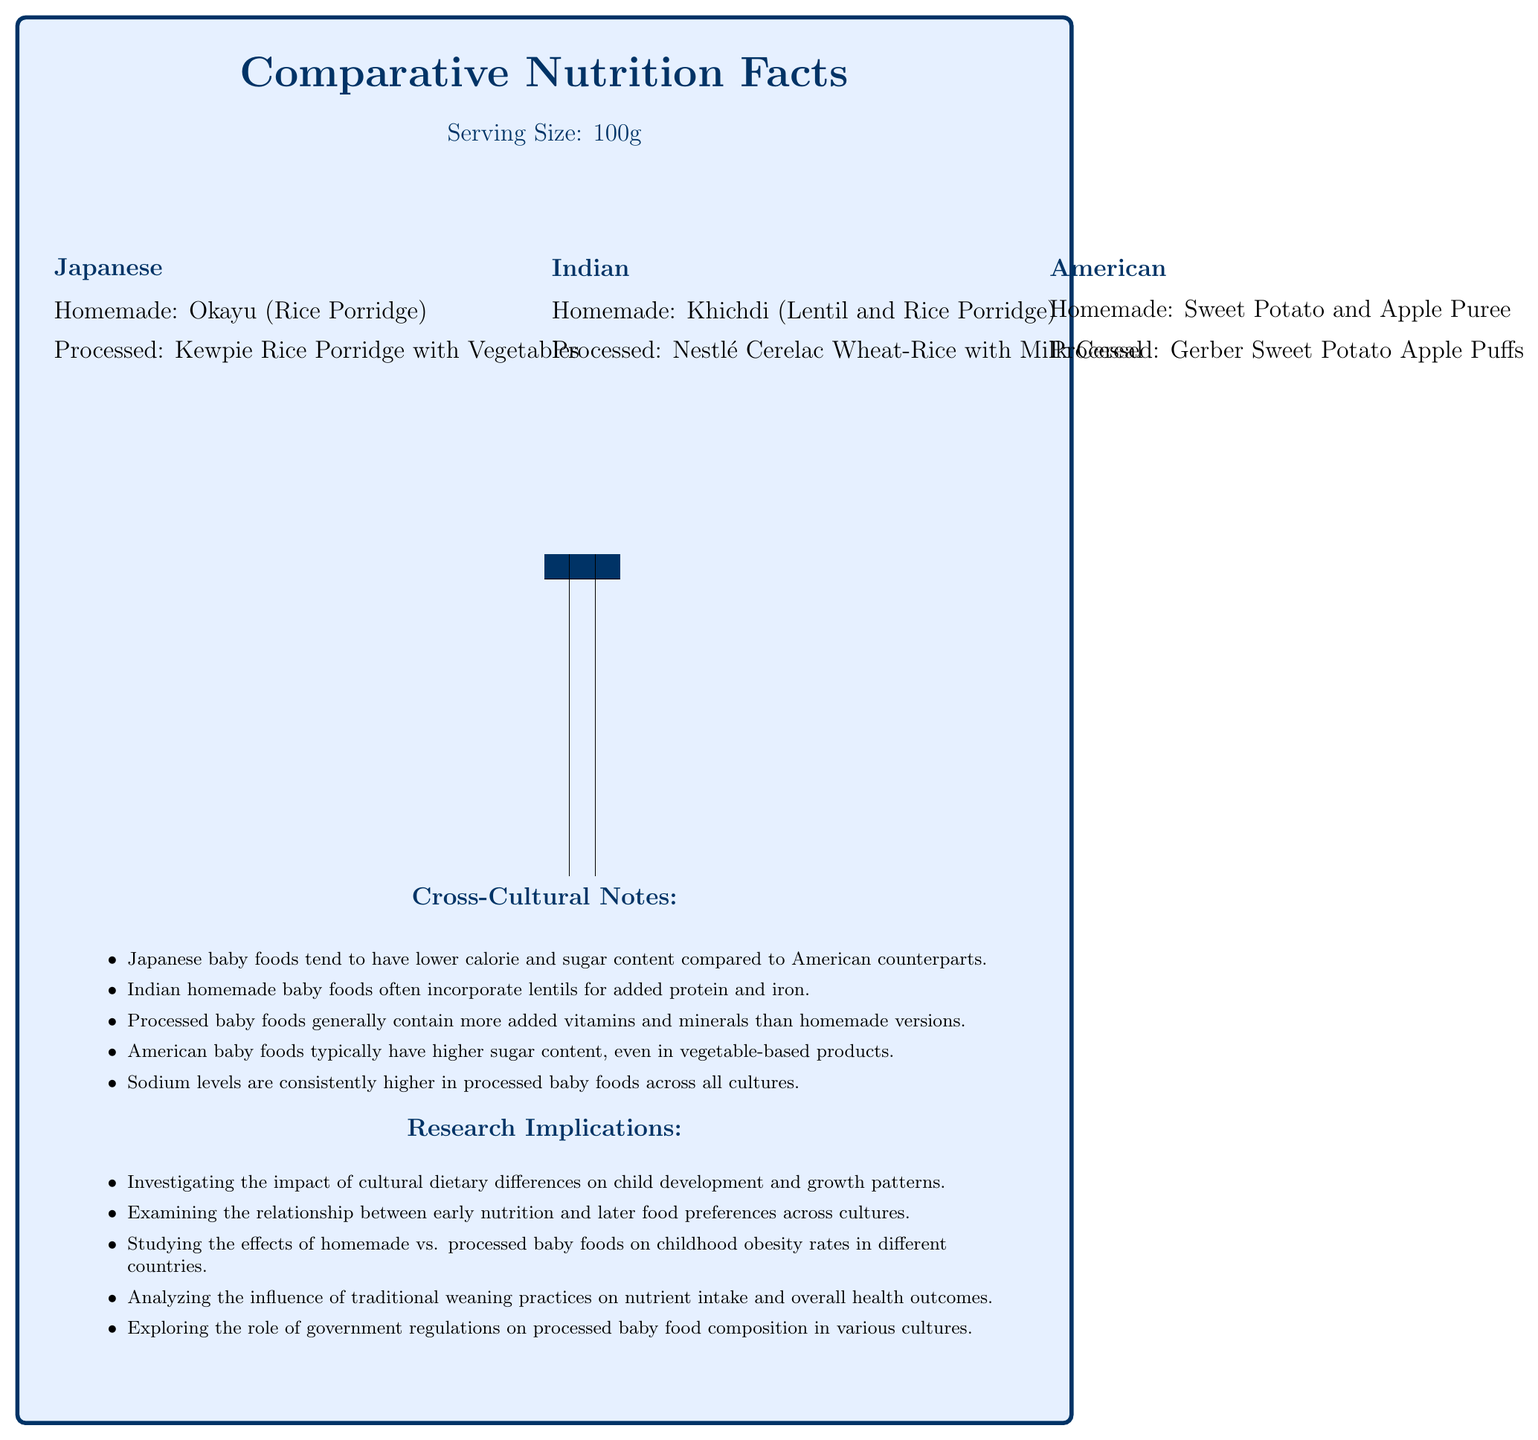What is the serving size for the baby foods compared in the document? The document states at the beginning that the serving size is 100g.
Answer: 100g Which processed baby food has the highest calorie content? A. Kewpie Rice Porridge with Vegetables B. Nestlé Cerelac Wheat-Rice with Milk Cereal C. Gerber Sweet Potato Apple Puffs D. Homemade Khichdi According to the comparative tables, the calorie content of "Kewpie Rice Porridge with Vegetables" is 52 kcal, "Nestlé Cerelac Wheat-Rice with Milk Cereal" is 101 kcal, and "Gerber Sweet Potato Apple Puffs" is 110 kcal. Therefore, Gerber Sweet Potato Apple Puffs has the highest calorie content among the processed foods.
Answer: C. Gerber Sweet Potato Apple Puffs Which culture's homemade baby food provides the most dietary fiber per serving? A. Japanese B. Indian C. American The document shows that the dietary fiber content in homemade baby foods is 0.3g (Japanese), 2.1g (Indian), and 2.3g (American). Therefore, the Indian homemade baby food (Khichdi) provides the most dietary fiber.
Answer: B. Indian Do American baby foods have higher sugar content compared to Japanese baby foods? The cross-cultural notes section of the document mentions that American baby foods have higher sugar content compared to Japanese counterparts.
Answer: Yes How much protein do the American homemade and processed baby foods have? The American section of the comparative tables shows that the protein content in homemade Sweet Potato and Apple Puree is 0.9g, and the protein content in processed Gerber Sweet Potato Apple Puffs is 1g.
Answer: Homemade: 0.9g, Processed: 1g Which homemade baby food contains the most calcium (%)? According to the comparative tables, the calcium content in homemade baby foods is 2% (Japanese), 15% (Indian), and 20% (American). Therefore, American Sweet Potato and Apple Puree contains the most calcium among homemade foods.
Answer: Khichdi (Indian) Which vitamin is consistently higher in processed baby foods than in homemade across all cultures? All processed baby foods listed in the document (Japanese, Indian, and American) have higher vitamin A content compared to their homemade counterparts.
Answer: Vitamin A Summarize the main insights provided by the document. The document provides detailed nutritional comparisons and discusses implications for child development and nutrition research across different cultures.
Answer: The document compares the nutritional content of homemade and processed baby foods from Japanese, Indian, and American cultures. It shows differences in calories, fats, sugars, vitamins, and minerals. Cross-cultural notes highlight tendencies such as lower sugar content in Japanese foods and higher protein in Indian foods. The research implications suggest studying the impact of these differences on child health and examining traditional versus processed food influences. What is the sodium content in Japanese processed baby food? The Japanese section of the comparative tables shows that the sodium content in the processed baby food (Kewpie Rice Porridge with Vegetables) is 20 mg.
Answer: 20 mg Are Indian homemade baby foods higher in total carbohydrate content compared to processed Indian baby foods? The comparative tables show that the total carbohydrate content in homemade Khichdi (Indian) is 15.6g, whereas in processed Nestlé Cerelac Wheat-Rice with Milk Cereal it's 16.8g. Thus, processed Indian baby foods have higher carbohydrate content.
Answer: No What is the cholesterol content in homemade American baby food? According to the comparative tables, the cholesterol content in homemade Sweet Potato and Apple Puree (American) is 0 mg.
Answer: 0 mg Which processed baby food has the highest percentage of daily value for calcium? A. Kewpie Rice Porridge with Vegetables B. Nestlé Cerelac Wheat-Rice with Milk Cereal C. Gerber Sweet Potato Apple Puffs The comparative tables indicate that the calcium content in processed foods is 10% DV (Kewpie Rice Porridge with Vegetables), 80% DV (Nestlé Cerelac Wheat-Rice with Milk Cereal), and 40% DV (Gerber Sweet Potato Apple Puffs). Therefore, Nestlé Cerelac Wheat-Rice with Milk Cereal has the highest calcium content.
Answer: B. Nestlé Cerelac Wheat-Rice with Milk Cereal What effect might high sodium levels in processed baby foods have on children across cultures? The document does not provide enough specific information about the effects of high sodium levels on children; it only notes that sodium levels are consistently higher in processed baby foods.
Answer: Cannot be determined 